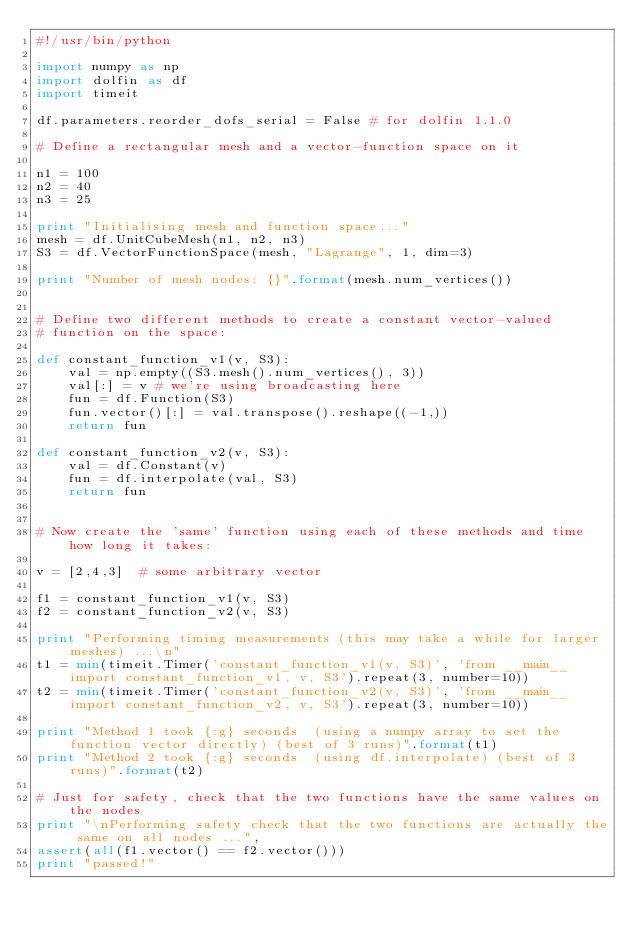<code> <loc_0><loc_0><loc_500><loc_500><_Python_>#!/usr/bin/python

import numpy as np
import dolfin as df
import timeit

df.parameters.reorder_dofs_serial = False # for dolfin 1.1.0

# Define a rectangular mesh and a vector-function space on it

n1 = 100
n2 = 40
n3 = 25

print "Initialising mesh and function space..."
mesh = df.UnitCubeMesh(n1, n2, n3)
S3 = df.VectorFunctionSpace(mesh, "Lagrange", 1, dim=3)

print "Number of mesh nodes: {}".format(mesh.num_vertices())


# Define two different methods to create a constant vector-valued
# function on the space:

def constant_function_v1(v, S3):
    val = np.empty((S3.mesh().num_vertices(), 3))
    val[:] = v # we're using broadcasting here
    fun = df.Function(S3)
    fun.vector()[:] = val.transpose().reshape((-1,))
    return fun

def constant_function_v2(v, S3):
    val = df.Constant(v)
    fun = df.interpolate(val, S3)
    return fun


# Now create the 'same' function using each of these methods and time how long it takes:

v = [2,4,3]  # some arbitrary vector

f1 = constant_function_v1(v, S3)
f2 = constant_function_v2(v, S3)

print "Performing timing measurements (this may take a while for larger meshes) ...\n"
t1 = min(timeit.Timer('constant_function_v1(v, S3)', 'from __main__ import constant_function_v1, v, S3').repeat(3, number=10))
t2 = min(timeit.Timer('constant_function_v2(v, S3)', 'from __main__ import constant_function_v2, v, S3').repeat(3, number=10))

print "Method 1 took {:g} seconds  (using a numpy array to set the function vector directly) (best of 3 runs)".format(t1)
print "Method 2 took {:g} seconds  (using df.interpolate) (best of 3 runs)".format(t2)

# Just for safety, check that the two functions have the same values on the nodes
print "\nPerforming safety check that the two functions are actually the same on all nodes ...",
assert(all(f1.vector() == f2.vector()))
print "passed!"
</code> 